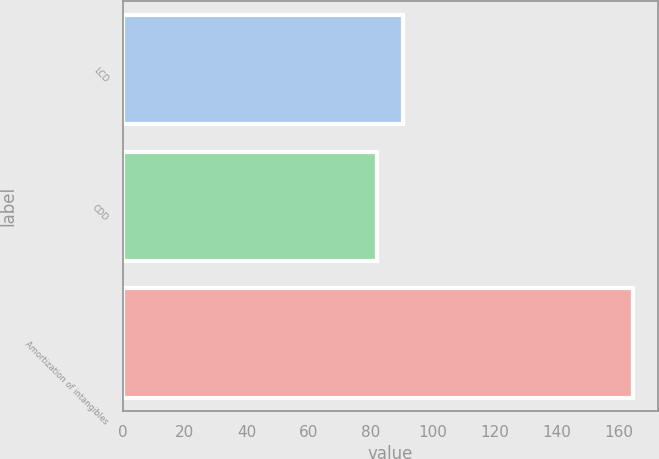Convert chart. <chart><loc_0><loc_0><loc_500><loc_500><bar_chart><fcel>LCD<fcel>CDD<fcel>Amortization of intangibles<nl><fcel>90.34<fcel>82.1<fcel>164.5<nl></chart> 